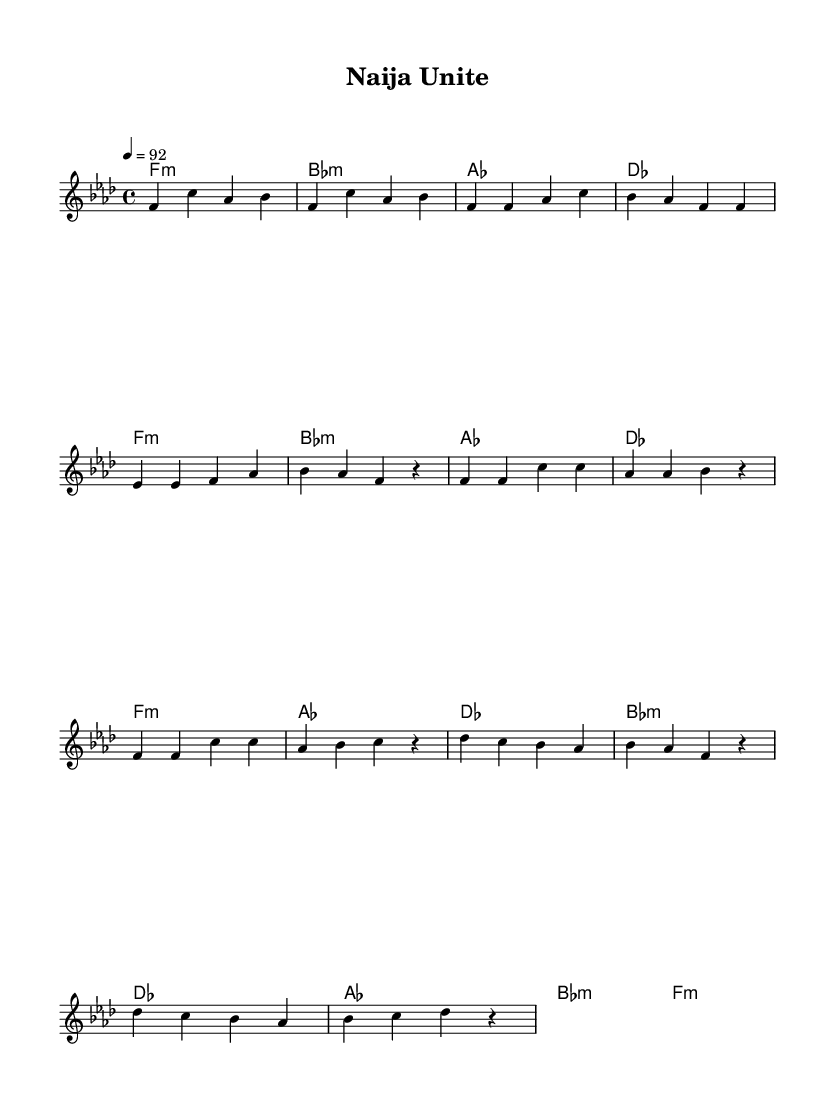What is the key signature of this music? The key signature is F minor, which has four flats (B♭, E♭, A♭, and D♭).
Answer: F minor What is the time signature of this music? The time signature is indicated as 4/4, which means there are four beats in each measure, and a quarter note receives one beat.
Answer: 4/4 What is the tempo marking of this music? The tempo marking is given as "4 = 92", which indicates that the quarter note is to be played at a speed of 92 beats per minute.
Answer: 92 How many measures are in the chorus section? The chorus section is composed of four measures, counting each distinct grouping noted in the sheet music.
Answer: 4 What types of chords are used in the intro? The chords used in the intro are minor chords, namely F minor, B♭ minor, A♭, and D♭. The specific labeling of chords indicates their quality.
Answer: minor What is the primary theme of this hip-hop anthem based on the sheet music? The anthem focuses on passion and unity, expressed through the lyrics and the upbeat tempo, though these elements are implied rather than explicitly listed in the music.
Answer: passion and unity Which chord appears first in the verse section? The first chord in the verse section is F minor, as it is listed first in the harmonic progression.
Answer: F minor 